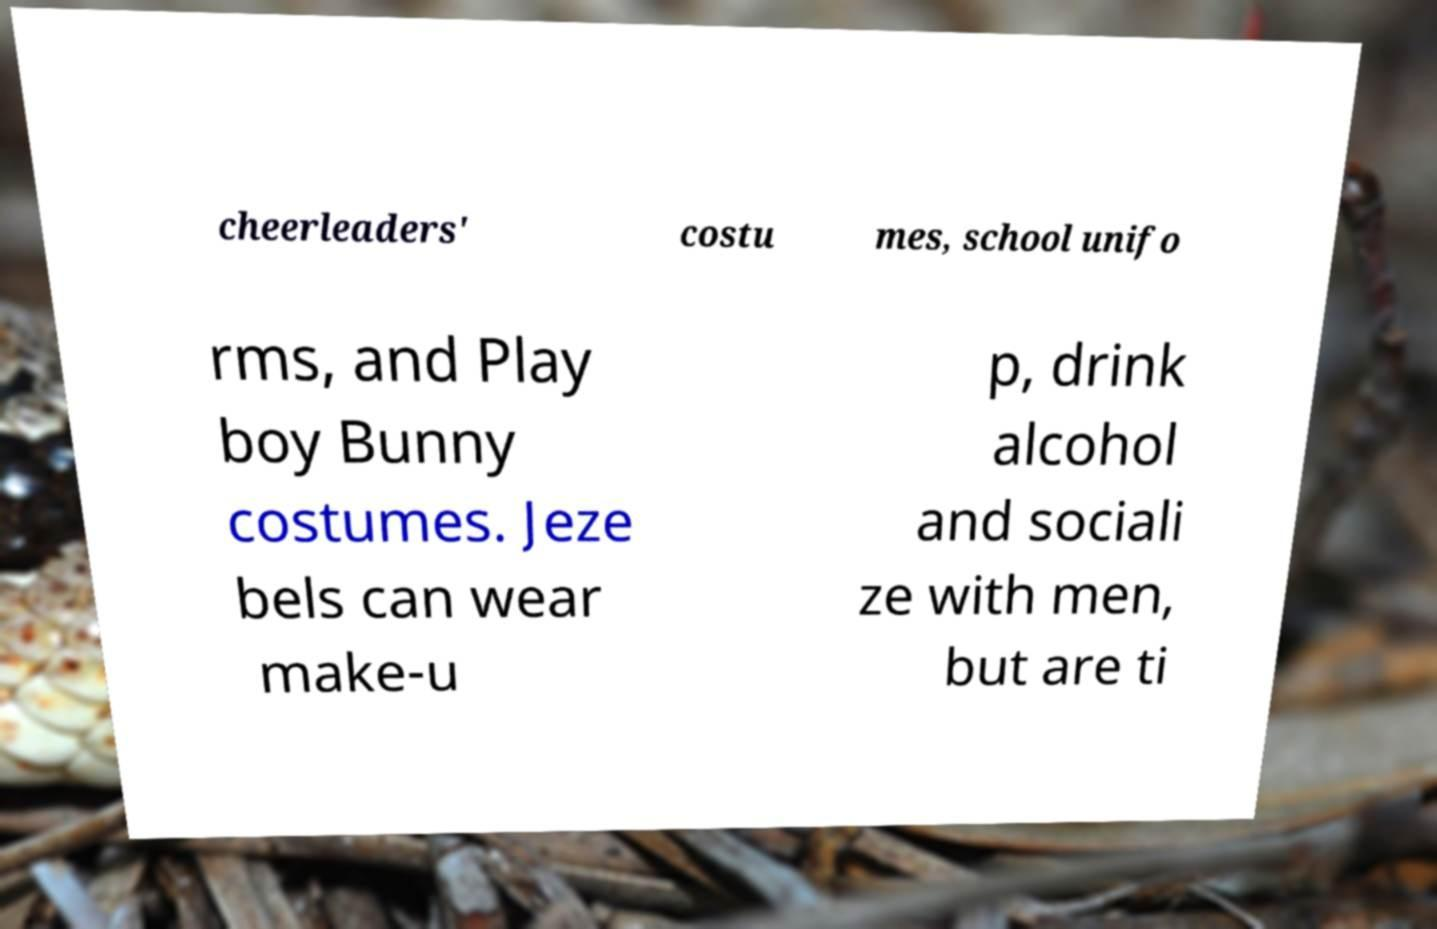What messages or text are displayed in this image? I need them in a readable, typed format. cheerleaders' costu mes, school unifo rms, and Play boy Bunny costumes. Jeze bels can wear make-u p, drink alcohol and sociali ze with men, but are ti 